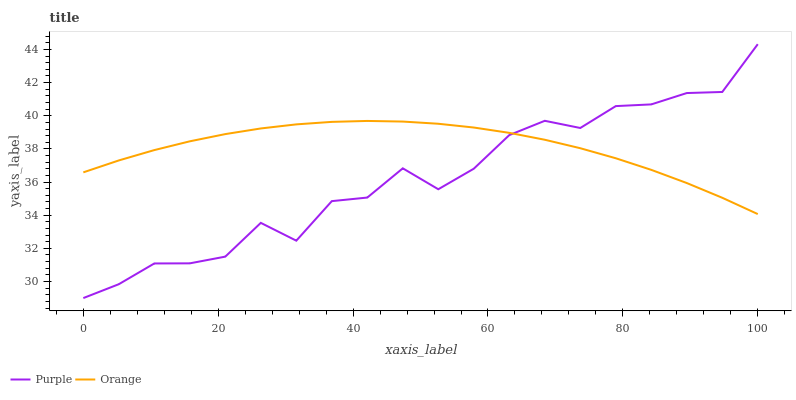Does Purple have the minimum area under the curve?
Answer yes or no. Yes. Does Orange have the maximum area under the curve?
Answer yes or no. Yes. Does Orange have the minimum area under the curve?
Answer yes or no. No. Is Orange the smoothest?
Answer yes or no. Yes. Is Purple the roughest?
Answer yes or no. Yes. Is Orange the roughest?
Answer yes or no. No. Does Orange have the lowest value?
Answer yes or no. No. Does Purple have the highest value?
Answer yes or no. Yes. Does Orange have the highest value?
Answer yes or no. No. Does Purple intersect Orange?
Answer yes or no. Yes. Is Purple less than Orange?
Answer yes or no. No. Is Purple greater than Orange?
Answer yes or no. No. 